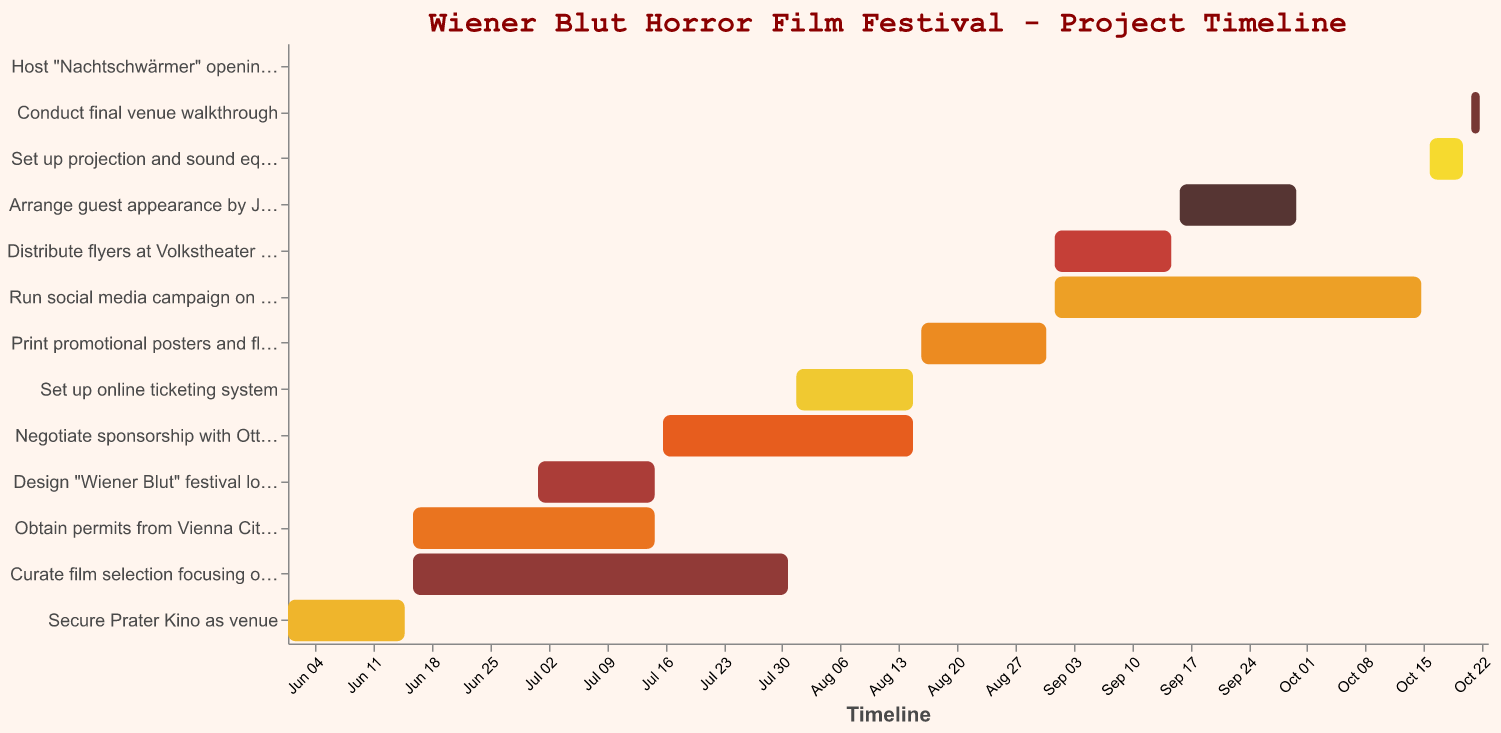What is the date range for securing the Prater Kino as the venue? The task "Secure Prater Kino as venue" starts on June 1, 2023, and ends on June 15, 2023. This can be seen on the bar representing this task in the chart.
Answer: June 1 to June 15 Which task has the longest duration in the project timeline? Observing the lengths of the bars, the "Curate film selection focusing on Austrian horror" task has the longest duration, starting on June 16, 2023, and ending on July 31, 2023, giving it a duration of 45 days.
Answer: Curate film selection focusing on Austrian horror When does the task involving "Design 'Wiener Blut' festival logo and branding" take place? This task starts on July 1, 2023, and ends on July 15, 2023. The corresponding bar in the chart indicates these dates.
Answer: July 1 to July 15 Which tasks are in progress simultaneously with "Print promotional posters and flyers"? "Print promotional posters and flyers" takes place from August 16, 2023, to August 31, 2023. During this period, the "Negotiate sponsorship with Ottakringer Brewery" task (until August 15) and the "Set up online ticketing system" task (until August 15) slightly overlap at the beginning of this timeframe.
Answer: Negotiate sponsorship with Ottakringer Brewery, Set up online ticketing system What is the overall timeline for organizing the horror film festival? The project spans from the earliest start date of June 1, 2023, for securing the venue to the latest end date of October 23, 2023, for hosting the opening night party. This is calculated by viewing the bars with the earliest start and latest end dates.
Answer: June 1 to October 23 How many tasks have a duration of exactly 14 days? Referring to the "Duration" column and the length of the corresponding bars, the following tasks have a duration of 14 days: "Secure Prater Kino as venue", "Design 'Wiener Blut' festival logo and branding", "Set up online ticketing system", "Distribute flyers at Volkstheater and Burgtheater", and "Arrange guest appearance by Jessica Hausner". That makes a total of 5 tasks.
Answer: 5 tasks Compare the durations of "Run social media campaign on Facebook and Instagram" and "Curate film selection focusing on Austrian horror". Which one takes longer? The "Run social media campaign" task has a duration of 44 days, running from September 1 to October 15, 2023, while the "Curate film selection" task lasts for 45 days, from June 16 to July 31, 2023. Comparing both durations, the "Curate film selection" task is longer by 1 day.
Answer: Curate film selection focusing on Austrian horror by 1 day Does any task end exactly on the same day another task starts? If yes, which ones? By checking the start and end dates, "Secure Prater Kino as venue" ends on June 15, 2023, and "Obtain permits from Vienna City Council" starts on June 16, 2023. Similarly, "Design 'Wiener Blut' festival logo and branding" ends on July 15, 2023, and "Negotiate sponsorship with Ottakringer Brewery" starts on July 16, 2023. Therefore, these list contains pairs of tasks with one ending and another starting consecutively.
Answer: Secure Prater Kino as venue & Obtain permits from Vienna City Council, Design 'Wiener Blut' festival logo and branding & Negotiate sponsorship with Ottakringer Brewery 